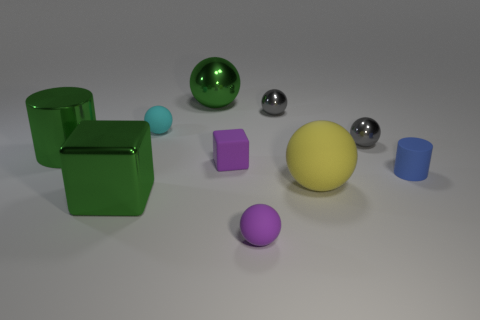Subtract all large green spheres. How many spheres are left? 5 Subtract all purple balls. How many balls are left? 5 Subtract all cyan balls. Subtract all red cylinders. How many balls are left? 5 Subtract all balls. How many objects are left? 4 Subtract 1 green balls. How many objects are left? 9 Subtract all small gray matte balls. Subtract all rubber blocks. How many objects are left? 9 Add 1 large green shiny balls. How many large green shiny balls are left? 2 Add 6 small blue rubber blocks. How many small blue rubber blocks exist? 6 